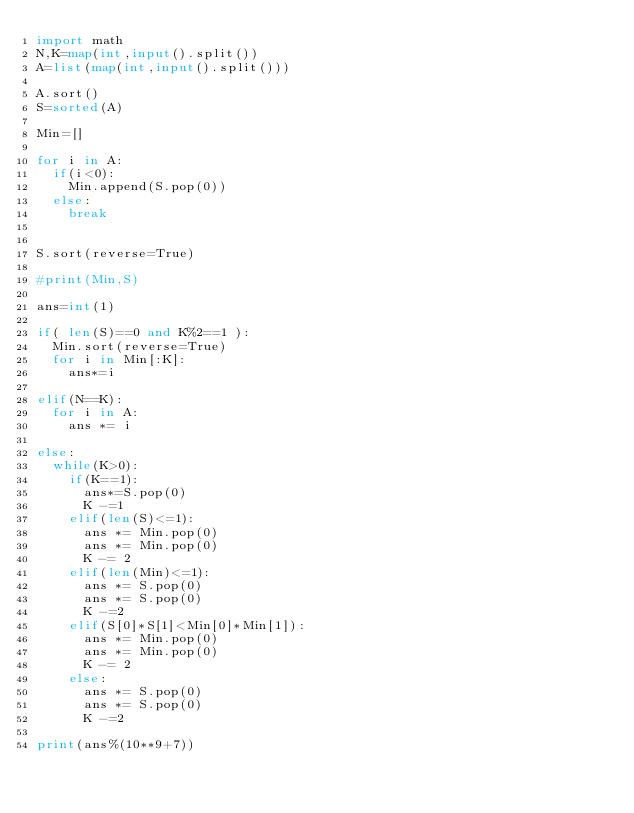<code> <loc_0><loc_0><loc_500><loc_500><_Python_>import math
N,K=map(int,input().split())
A=list(map(int,input().split()))

A.sort()
S=sorted(A)

Min=[]

for i in A:
  if(i<0):
    Min.append(S.pop(0))
  else:
    break


S.sort(reverse=True)

#print(Min,S)

ans=int(1)

if( len(S)==0 and K%2==1 ):
  Min.sort(reverse=True)
  for i in Min[:K]:
    ans*=i

elif(N==K):
  for i in A:
    ans *= i

else:
  while(K>0):
    if(K==1):
      ans*=S.pop(0)
      K -=1
    elif(len(S)<=1):
      ans *= Min.pop(0)
      ans *= Min.pop(0)
      K -= 2
    elif(len(Min)<=1):
      ans *= S.pop(0)
      ans *= S.pop(0)
      K -=2
    elif(S[0]*S[1]<Min[0]*Min[1]):
      ans *= Min.pop(0)
      ans *= Min.pop(0)
      K -= 2
    else:
      ans *= S.pop(0)
      ans *= S.pop(0)
      K -=2

print(ans%(10**9+7))</code> 